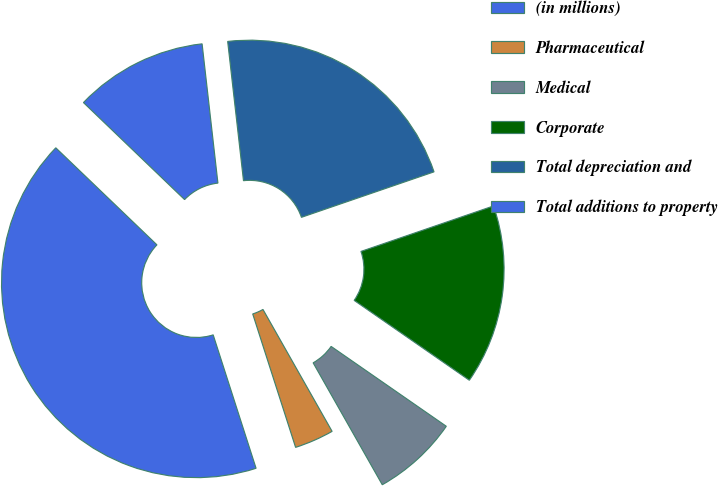<chart> <loc_0><loc_0><loc_500><loc_500><pie_chart><fcel>(in millions)<fcel>Pharmaceutical<fcel>Medical<fcel>Corporate<fcel>Total depreciation and<fcel>Total additions to property<nl><fcel>42.12%<fcel>3.26%<fcel>7.14%<fcel>14.91%<fcel>21.54%<fcel>11.03%<nl></chart> 